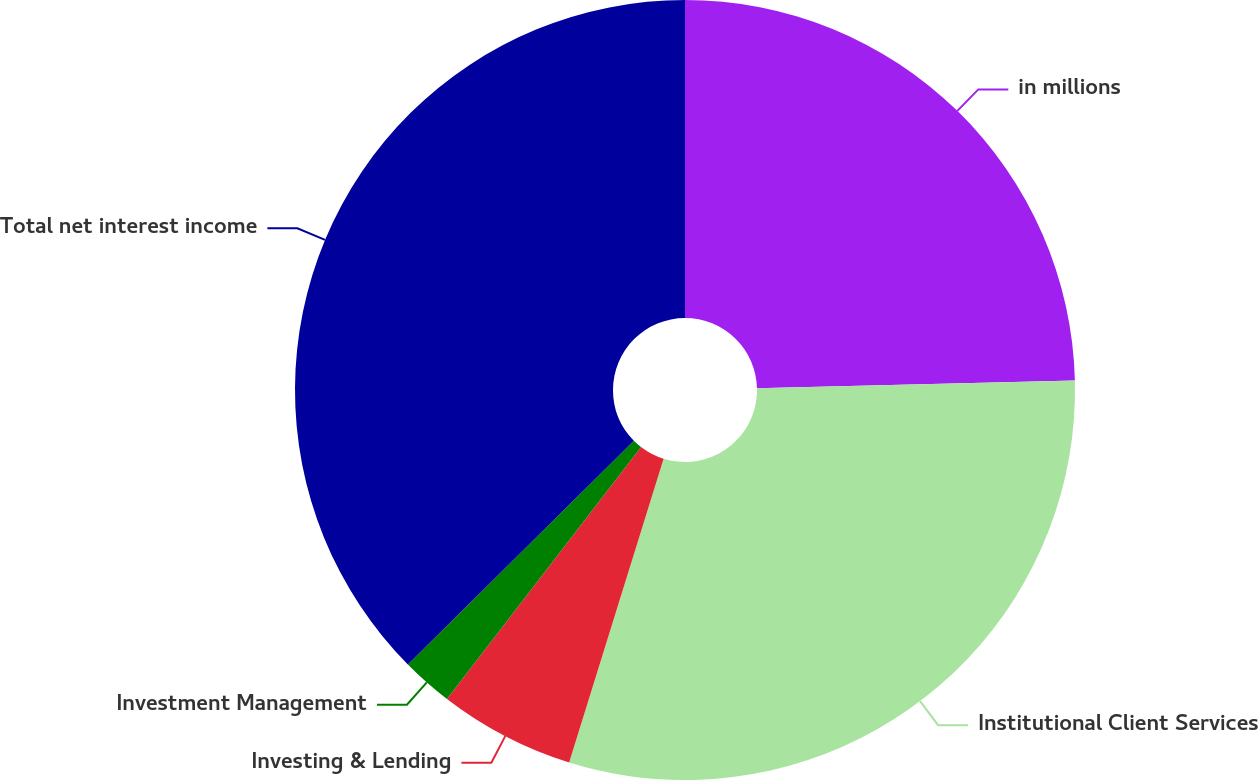Convert chart. <chart><loc_0><loc_0><loc_500><loc_500><pie_chart><fcel>in millions<fcel>Institutional Client Services<fcel>Investing & Lending<fcel>Investment Management<fcel>Total net interest income<nl><fcel>24.61%<fcel>30.19%<fcel>5.65%<fcel>2.13%<fcel>37.42%<nl></chart> 